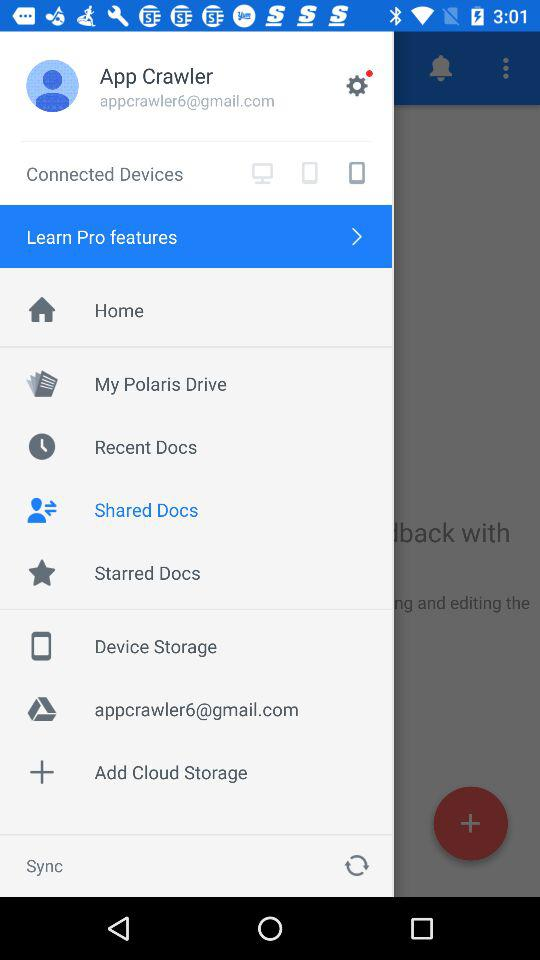What is the selected option? The selected option is "Shared Docs". 